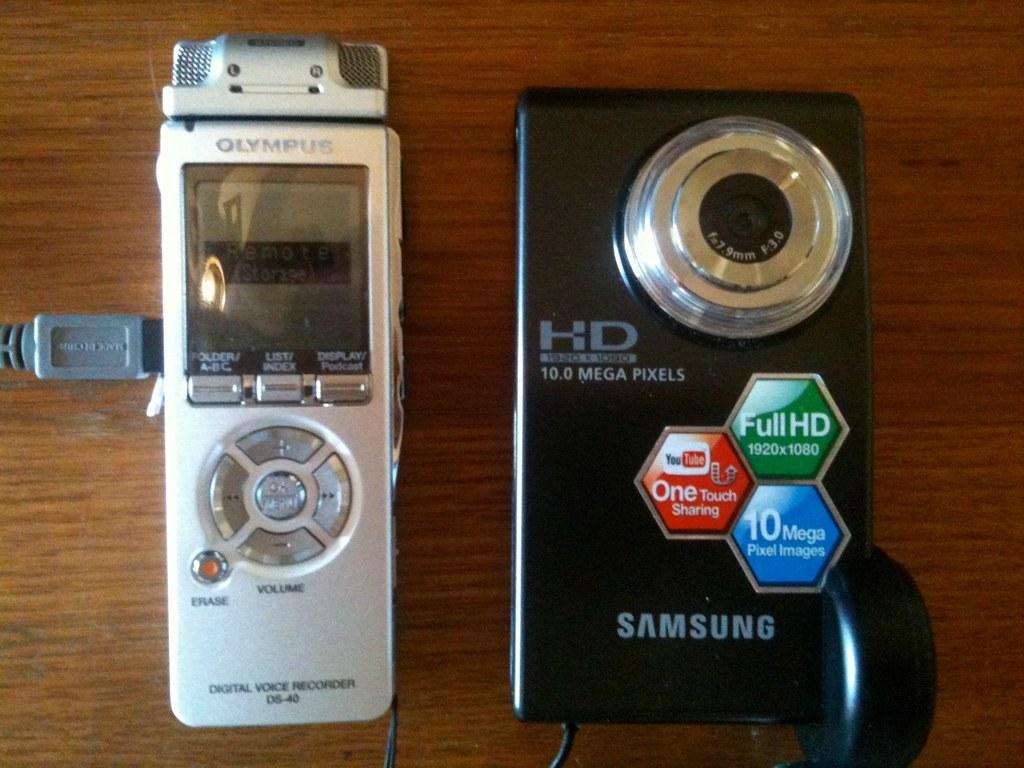How many mega pixels does this camera have?
Provide a short and direct response. 10. 